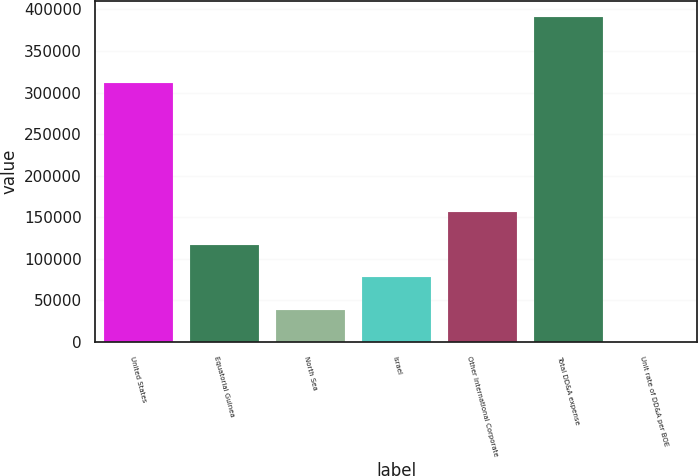Convert chart. <chart><loc_0><loc_0><loc_500><loc_500><bar_chart><fcel>United States<fcel>Equatorial Guinea<fcel>North Sea<fcel>Israel<fcel>Other International Corporate<fcel>Total DD&A expense<fcel>Unit rate of DD&A per BOE<nl><fcel>311153<fcel>117168<fcel>39061.2<fcel>78114.9<fcel>156222<fcel>390544<fcel>7.55<nl></chart> 